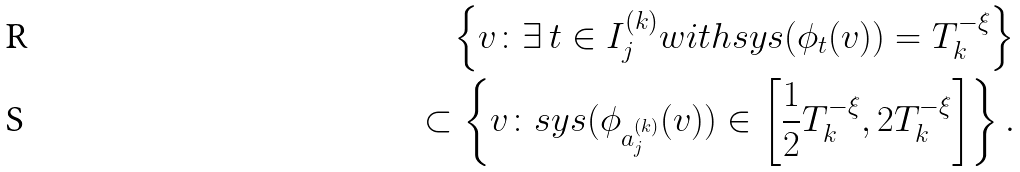Convert formula to latex. <formula><loc_0><loc_0><loc_500><loc_500>\left \{ v \colon \exists \, t \in I _ { j } ^ { ( k ) } w i t h s y s ( \phi _ { t } ( v ) ) = T _ { k } ^ { - \xi } \right \} \\ \subset \left \{ v \colon s y s ( \phi _ { a _ { j } ^ { ( k ) } } ( v ) ) \in \left [ \frac { 1 } { 2 } T _ { k } ^ { - \xi } , 2 T _ { k } ^ { - \xi } \right ] \right \} .</formula> 